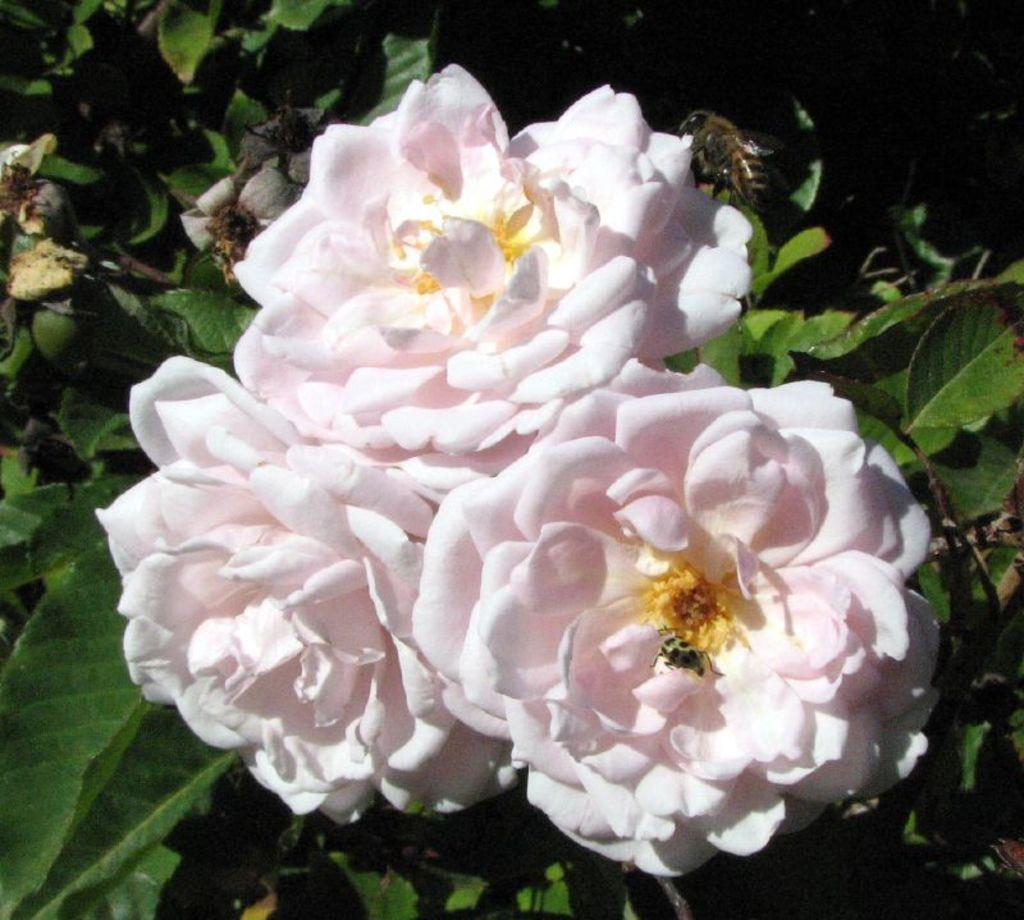What is the focus of the image? The image is zoomed in on flowers in the center. Can you describe the flowers in the image? Unfortunately, the image is too zoomed in to provide a detailed description of the flowers. What else can be seen in the background of the image? In the background, there is an insect and leaves of a plant. How many horses are visible in the image? There are no horses present in the image. What type of pail is being used to water the flowers in the image? There is no pail visible in the image; it only shows flowers, an insect, and plant leaves. 